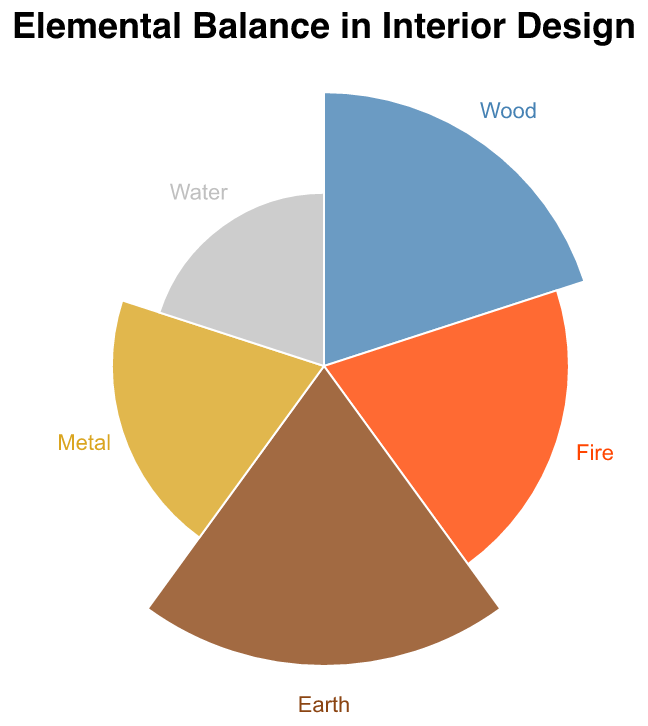How many elements are represented in the chart? To determine this, look at the number of unique elements labeled on the chart. The chart includes Wood, Fire, Earth, Metal, and Water.
Answer: 5 Which element has the highest proportion in the interior design themes? By observing the lengths of the radial bars, Earth stands out as having the longest bar, indicating the highest proportion.
Answer: Earth What is the total proportion of the elements Wood and Fire combined? Wood has a proportion of 25, and Fire has a proportion of 20. Adding them together, 25 + 20 equals 45.
Answer: 45 How does the proportion of Water compare to the proportion of Metal? Comparing the radial lengths of Water and Metal, Water has a proportion of 10 while Metal has a proportion of 15. Hence, Metal has a higher proportion than Water.
Answer: Metal is higher What percentage of the total proportion does Earth represent? The total proportion is the sum of all elements: 25 (Wood) + 20 (Fire) + 30 (Earth) + 15 (Metal) + 10 (Water) = 100. Earth's proportion is 30. Therefore, (30/100) * 100% = 30%.
Answer: 30% By how much does the proportion of Wood exceed that of Water? Wood has a proportion of 25, and Water has a proportion of 10. The difference is 25 - 10.
Answer: 15 Which elements combined have an equal proportion to Earth? Earth's proportion is 30. The sum of Fire (20) and Water (10) is 20 + 10 = 30, which equals Earth's proportion.
Answer: Fire and Water If the design were to require an equal balance of all elements, how much would the proportion of Metal need to be increased? An equal balance means each of the 5 elements would take 20% (100/5) of the proportion. Metal currently has 15%. Therefore, it needs an increase of 20 - 15 = 5.
Answer: 5 Which element has the smallest proportion, and by how much is it smaller than the highest one? Water has the smallest proportion at 10, and Earth has the highest at 30. The difference is 30 - 10.
Answer: 20 